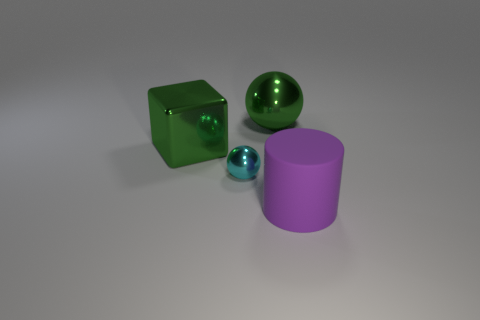There is another shiny object that is the same shape as the tiny cyan thing; what is its size?
Give a very brief answer. Large. There is a large thing that is both in front of the green sphere and left of the large matte cylinder; what is its shape?
Ensure brevity in your answer.  Cube. What is the color of the big metallic object that is the same shape as the small object?
Provide a succinct answer. Green. Does the small shiny thing have the same shape as the large rubber thing?
Keep it short and to the point. No. There is a big thing that is the same color as the cube; what is its shape?
Provide a succinct answer. Sphere. There is a sphere that is the same material as the tiny cyan object; what is its size?
Your response must be concise. Large. Is there anything else that has the same color as the large matte cylinder?
Your answer should be compact. No. There is a large shiny ball to the right of the green block; what color is it?
Provide a succinct answer. Green. There is a big thing that is right of the metal sphere behind the green metallic cube; are there any shiny blocks right of it?
Give a very brief answer. No. Is the number of big balls that are right of the large green sphere greater than the number of big gray shiny balls?
Keep it short and to the point. No. 